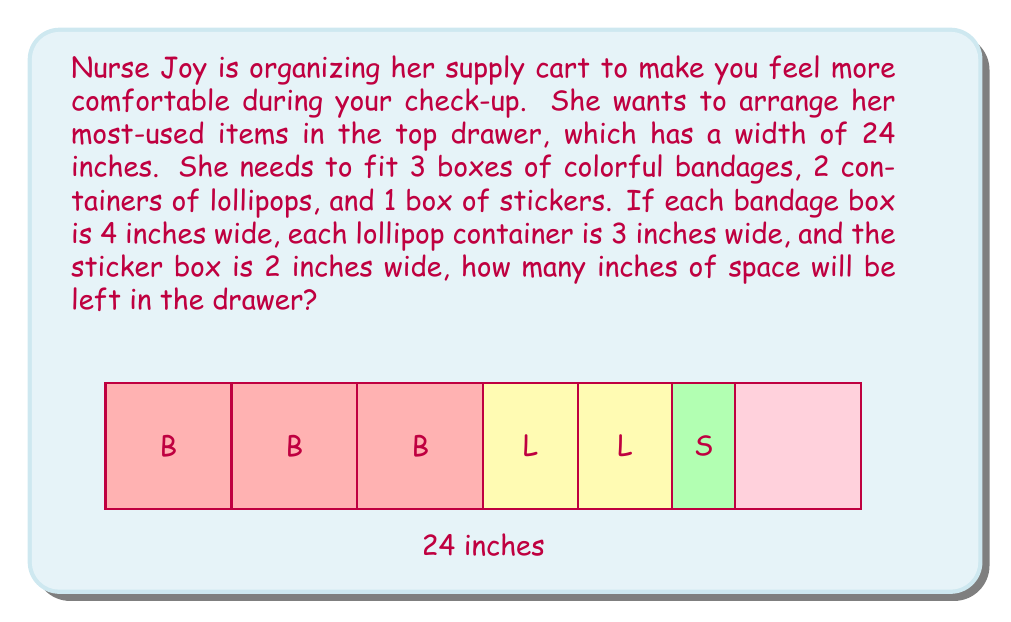Show me your answer to this math problem. Let's solve this problem step by step:

1) First, let's calculate the total width of all the items:
   - 3 bandage boxes: $3 \times 4$ inches = $12$ inches
   - 2 lollipop containers: $2 \times 3$ inches = $6$ inches
   - 1 sticker box: $1 \times 2$ inches = $2$ inches

2) Now, let's add up all these widths:
   $$ 12 + 6 + 2 = 20 \text{ inches} $$

3) The drawer's total width is 24 inches. To find the space left, we subtract the total width of the items from the drawer's width:
   $$ 24 - 20 = 4 \text{ inches} $$

Therefore, there will be 4 inches of space left in the drawer.
Answer: 4 inches 